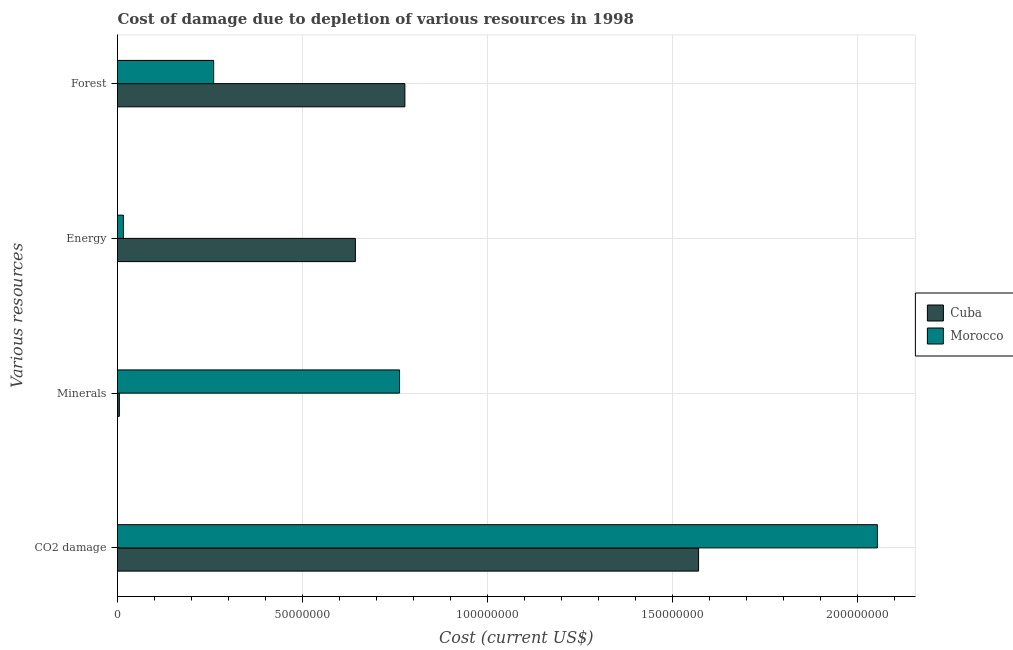How many bars are there on the 1st tick from the bottom?
Provide a short and direct response. 2. What is the label of the 3rd group of bars from the top?
Give a very brief answer. Minerals. What is the cost of damage due to depletion of energy in Morocco?
Your response must be concise. 1.59e+06. Across all countries, what is the maximum cost of damage due to depletion of coal?
Keep it short and to the point. 2.05e+08. Across all countries, what is the minimum cost of damage due to depletion of minerals?
Offer a terse response. 4.98e+05. In which country was the cost of damage due to depletion of coal maximum?
Make the answer very short. Morocco. In which country was the cost of damage due to depletion of energy minimum?
Make the answer very short. Morocco. What is the total cost of damage due to depletion of forests in the graph?
Your answer should be very brief. 1.04e+08. What is the difference between the cost of damage due to depletion of minerals in Cuba and that in Morocco?
Your answer should be compact. -7.57e+07. What is the difference between the cost of damage due to depletion of minerals in Morocco and the cost of damage due to depletion of forests in Cuba?
Ensure brevity in your answer.  -1.44e+06. What is the average cost of damage due to depletion of energy per country?
Provide a short and direct response. 3.29e+07. What is the difference between the cost of damage due to depletion of minerals and cost of damage due to depletion of energy in Morocco?
Keep it short and to the point. 7.46e+07. What is the ratio of the cost of damage due to depletion of forests in Cuba to that in Morocco?
Provide a succinct answer. 2.99. Is the cost of damage due to depletion of minerals in Cuba less than that in Morocco?
Give a very brief answer. Yes. What is the difference between the highest and the second highest cost of damage due to depletion of forests?
Your answer should be compact. 5.17e+07. What is the difference between the highest and the lowest cost of damage due to depletion of coal?
Provide a succinct answer. 4.83e+07. In how many countries, is the cost of damage due to depletion of energy greater than the average cost of damage due to depletion of energy taken over all countries?
Offer a terse response. 1. What does the 1st bar from the top in CO2 damage represents?
Offer a very short reply. Morocco. What does the 2nd bar from the bottom in Minerals represents?
Keep it short and to the point. Morocco. How many bars are there?
Offer a very short reply. 8. How many countries are there in the graph?
Give a very brief answer. 2. Are the values on the major ticks of X-axis written in scientific E-notation?
Provide a short and direct response. No. Where does the legend appear in the graph?
Keep it short and to the point. Center right. How are the legend labels stacked?
Your answer should be compact. Vertical. What is the title of the graph?
Keep it short and to the point. Cost of damage due to depletion of various resources in 1998 . What is the label or title of the X-axis?
Provide a short and direct response. Cost (current US$). What is the label or title of the Y-axis?
Offer a very short reply. Various resources. What is the Cost (current US$) of Cuba in CO2 damage?
Keep it short and to the point. 1.57e+08. What is the Cost (current US$) of Morocco in CO2 damage?
Provide a succinct answer. 2.05e+08. What is the Cost (current US$) of Cuba in Minerals?
Make the answer very short. 4.98e+05. What is the Cost (current US$) of Morocco in Minerals?
Provide a short and direct response. 7.62e+07. What is the Cost (current US$) in Cuba in Energy?
Your answer should be compact. 6.43e+07. What is the Cost (current US$) of Morocco in Energy?
Make the answer very short. 1.59e+06. What is the Cost (current US$) of Cuba in Forest?
Offer a very short reply. 7.76e+07. What is the Cost (current US$) in Morocco in Forest?
Offer a very short reply. 2.60e+07. Across all Various resources, what is the maximum Cost (current US$) of Cuba?
Give a very brief answer. 1.57e+08. Across all Various resources, what is the maximum Cost (current US$) in Morocco?
Keep it short and to the point. 2.05e+08. Across all Various resources, what is the minimum Cost (current US$) of Cuba?
Provide a short and direct response. 4.98e+05. Across all Various resources, what is the minimum Cost (current US$) of Morocco?
Offer a terse response. 1.59e+06. What is the total Cost (current US$) of Cuba in the graph?
Ensure brevity in your answer.  2.99e+08. What is the total Cost (current US$) of Morocco in the graph?
Give a very brief answer. 3.09e+08. What is the difference between the Cost (current US$) of Cuba in CO2 damage and that in Minerals?
Your answer should be compact. 1.56e+08. What is the difference between the Cost (current US$) in Morocco in CO2 damage and that in Minerals?
Keep it short and to the point. 1.29e+08. What is the difference between the Cost (current US$) in Cuba in CO2 damage and that in Energy?
Keep it short and to the point. 9.27e+07. What is the difference between the Cost (current US$) of Morocco in CO2 damage and that in Energy?
Keep it short and to the point. 2.04e+08. What is the difference between the Cost (current US$) of Cuba in CO2 damage and that in Forest?
Offer a very short reply. 7.93e+07. What is the difference between the Cost (current US$) in Morocco in CO2 damage and that in Forest?
Provide a succinct answer. 1.79e+08. What is the difference between the Cost (current US$) of Cuba in Minerals and that in Energy?
Make the answer very short. -6.38e+07. What is the difference between the Cost (current US$) in Morocco in Minerals and that in Energy?
Make the answer very short. 7.46e+07. What is the difference between the Cost (current US$) of Cuba in Minerals and that in Forest?
Ensure brevity in your answer.  -7.71e+07. What is the difference between the Cost (current US$) of Morocco in Minerals and that in Forest?
Ensure brevity in your answer.  5.02e+07. What is the difference between the Cost (current US$) of Cuba in Energy and that in Forest?
Keep it short and to the point. -1.34e+07. What is the difference between the Cost (current US$) in Morocco in Energy and that in Forest?
Offer a terse response. -2.44e+07. What is the difference between the Cost (current US$) of Cuba in CO2 damage and the Cost (current US$) of Morocco in Minerals?
Provide a succinct answer. 8.08e+07. What is the difference between the Cost (current US$) of Cuba in CO2 damage and the Cost (current US$) of Morocco in Energy?
Provide a short and direct response. 1.55e+08. What is the difference between the Cost (current US$) in Cuba in CO2 damage and the Cost (current US$) in Morocco in Forest?
Make the answer very short. 1.31e+08. What is the difference between the Cost (current US$) of Cuba in Minerals and the Cost (current US$) of Morocco in Energy?
Offer a terse response. -1.09e+06. What is the difference between the Cost (current US$) of Cuba in Minerals and the Cost (current US$) of Morocco in Forest?
Ensure brevity in your answer.  -2.55e+07. What is the difference between the Cost (current US$) of Cuba in Energy and the Cost (current US$) of Morocco in Forest?
Give a very brief answer. 3.83e+07. What is the average Cost (current US$) of Cuba per Various resources?
Keep it short and to the point. 7.48e+07. What is the average Cost (current US$) in Morocco per Various resources?
Keep it short and to the point. 7.73e+07. What is the difference between the Cost (current US$) of Cuba and Cost (current US$) of Morocco in CO2 damage?
Offer a terse response. -4.83e+07. What is the difference between the Cost (current US$) in Cuba and Cost (current US$) in Morocco in Minerals?
Offer a very short reply. -7.57e+07. What is the difference between the Cost (current US$) in Cuba and Cost (current US$) in Morocco in Energy?
Give a very brief answer. 6.27e+07. What is the difference between the Cost (current US$) in Cuba and Cost (current US$) in Morocco in Forest?
Your answer should be very brief. 5.17e+07. What is the ratio of the Cost (current US$) of Cuba in CO2 damage to that in Minerals?
Provide a short and direct response. 315.39. What is the ratio of the Cost (current US$) of Morocco in CO2 damage to that in Minerals?
Keep it short and to the point. 2.69. What is the ratio of the Cost (current US$) in Cuba in CO2 damage to that in Energy?
Your answer should be very brief. 2.44. What is the ratio of the Cost (current US$) of Morocco in CO2 damage to that in Energy?
Give a very brief answer. 129.01. What is the ratio of the Cost (current US$) in Cuba in CO2 damage to that in Forest?
Your response must be concise. 2.02. What is the ratio of the Cost (current US$) in Morocco in CO2 damage to that in Forest?
Your answer should be compact. 7.9. What is the ratio of the Cost (current US$) in Cuba in Minerals to that in Energy?
Your answer should be compact. 0.01. What is the ratio of the Cost (current US$) of Morocco in Minerals to that in Energy?
Your response must be concise. 47.89. What is the ratio of the Cost (current US$) in Cuba in Minerals to that in Forest?
Your response must be concise. 0.01. What is the ratio of the Cost (current US$) of Morocco in Minerals to that in Forest?
Ensure brevity in your answer.  2.93. What is the ratio of the Cost (current US$) of Cuba in Energy to that in Forest?
Your response must be concise. 0.83. What is the ratio of the Cost (current US$) of Morocco in Energy to that in Forest?
Keep it short and to the point. 0.06. What is the difference between the highest and the second highest Cost (current US$) in Cuba?
Your answer should be very brief. 7.93e+07. What is the difference between the highest and the second highest Cost (current US$) of Morocco?
Offer a very short reply. 1.29e+08. What is the difference between the highest and the lowest Cost (current US$) in Cuba?
Provide a short and direct response. 1.56e+08. What is the difference between the highest and the lowest Cost (current US$) in Morocco?
Your answer should be very brief. 2.04e+08. 